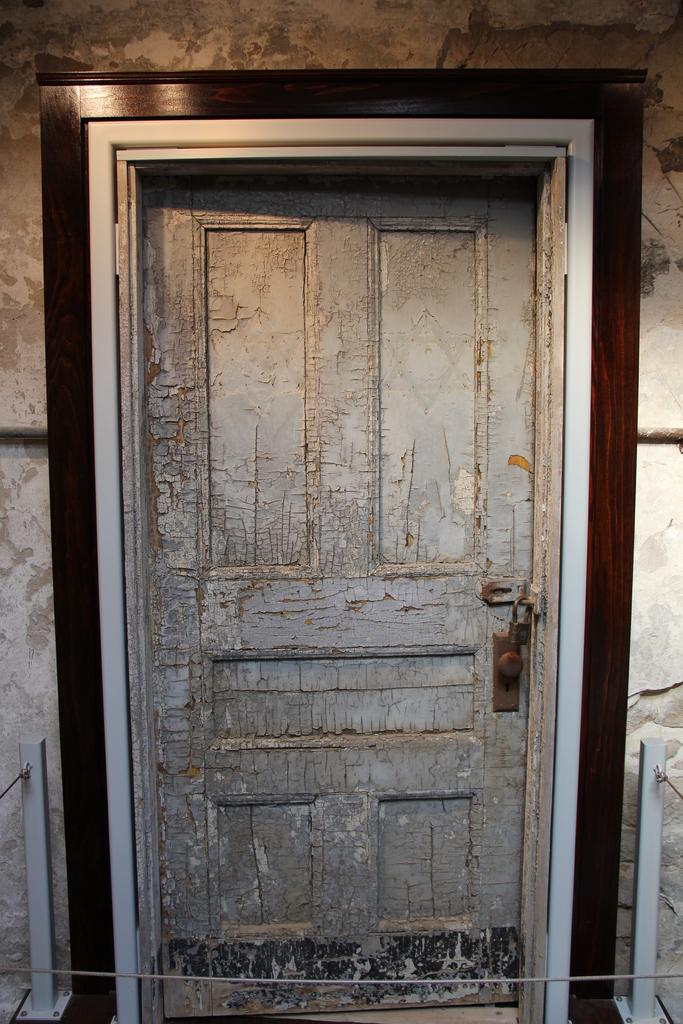What type of door is visible in the image? There is a wooden door in the image. Does the wooden door have any specific features? Yes, the wooden door has a lock. How many seeds are planted in the cart in the image? There is no cart or seeds present in the image; it only features a wooden door with a lock. 